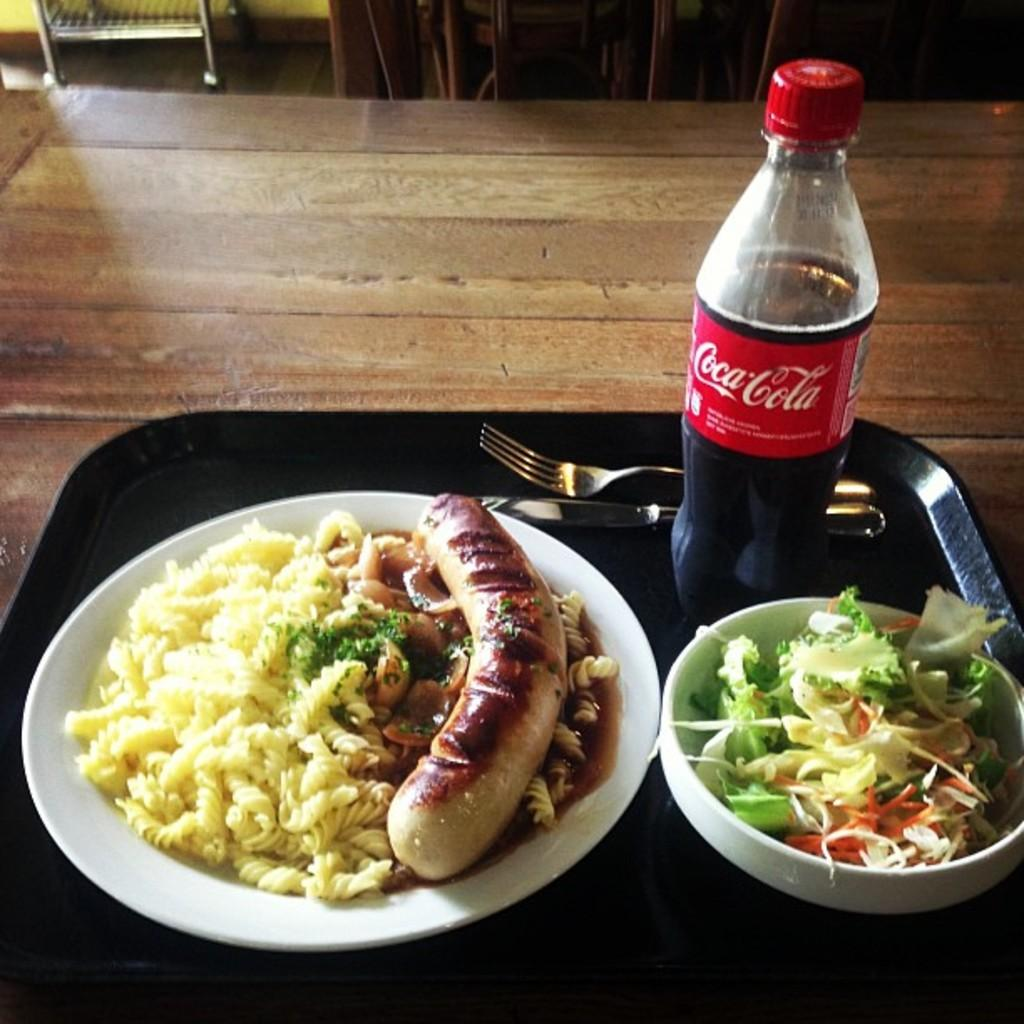What piece of furniture is present in the image? There is a table in the image. What is on the table? The table contains food, plates, a bottle, a knife, and a fork. How many utensils are on the table? There is a knife and a fork on the table. What type of string is used to tie the fruit in the image? There is no string or fruit present in the image. 